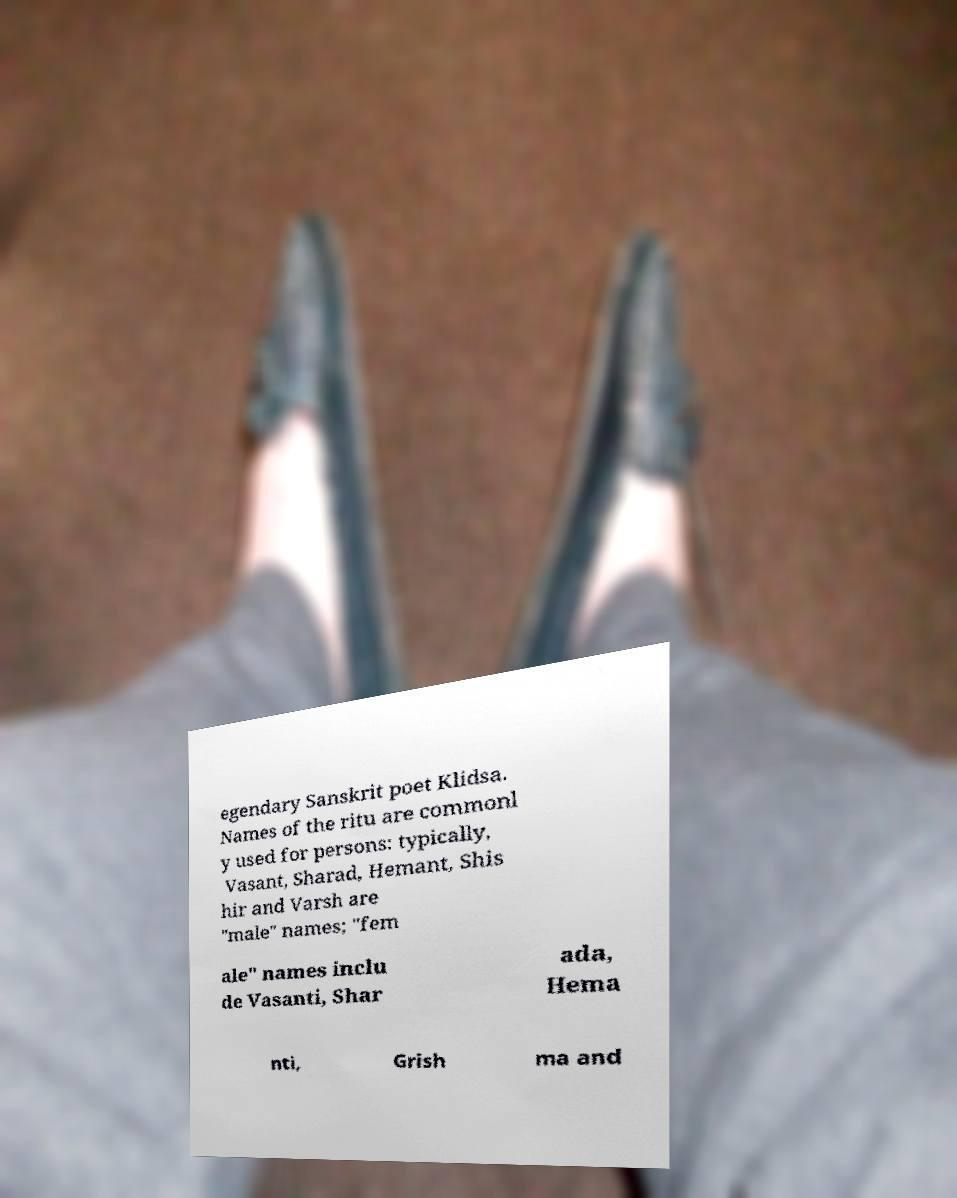For documentation purposes, I need the text within this image transcribed. Could you provide that? egendary Sanskrit poet Klidsa. Names of the ritu are commonl y used for persons: typically, Vasant, Sharad, Hemant, Shis hir and Varsh are "male" names; "fem ale" names inclu de Vasanti, Shar ada, Hema nti, Grish ma and 